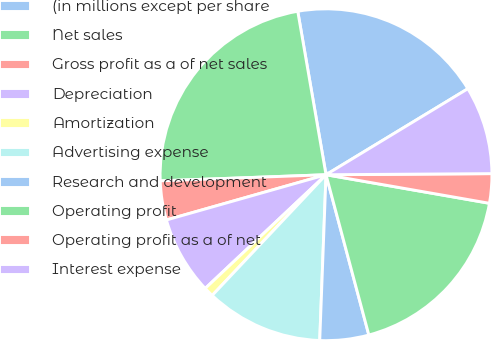<chart> <loc_0><loc_0><loc_500><loc_500><pie_chart><fcel>(in millions except per share<fcel>Net sales<fcel>Gross profit as a of net sales<fcel>Depreciation<fcel>Amortization<fcel>Advertising expense<fcel>Research and development<fcel>Operating profit<fcel>Operating profit as a of net<fcel>Interest expense<nl><fcel>19.05%<fcel>22.86%<fcel>3.81%<fcel>7.62%<fcel>0.95%<fcel>11.43%<fcel>4.76%<fcel>18.09%<fcel>2.86%<fcel>8.57%<nl></chart> 